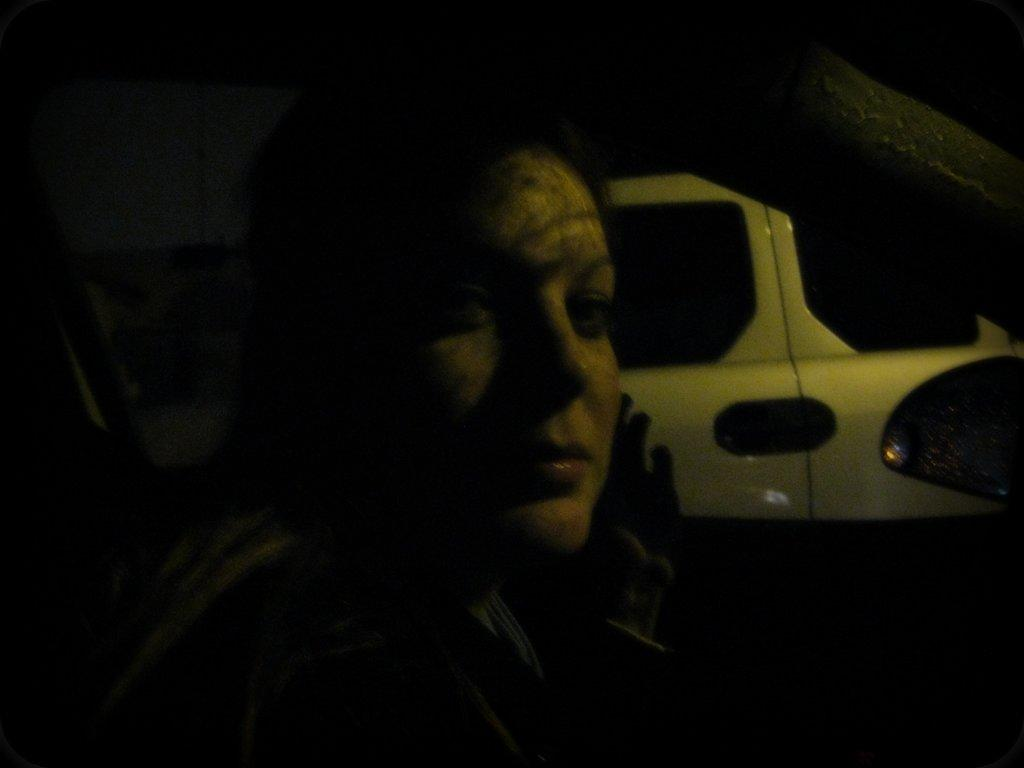What is the person in the image doing? There is a person sitting inside the vehicle in the image. What object can be seen in the image that is commonly used for self-reflection or safety? There is a mirror visible in the image. Can you describe the lighting conditions in the image? The image appears to be dark in the image. What type of insurance policy is mentioned in the image? There is no mention of insurance in the image. How many doors are visible in the image? There is no door visible in the image, as it only shows the interior of the vehicle. 